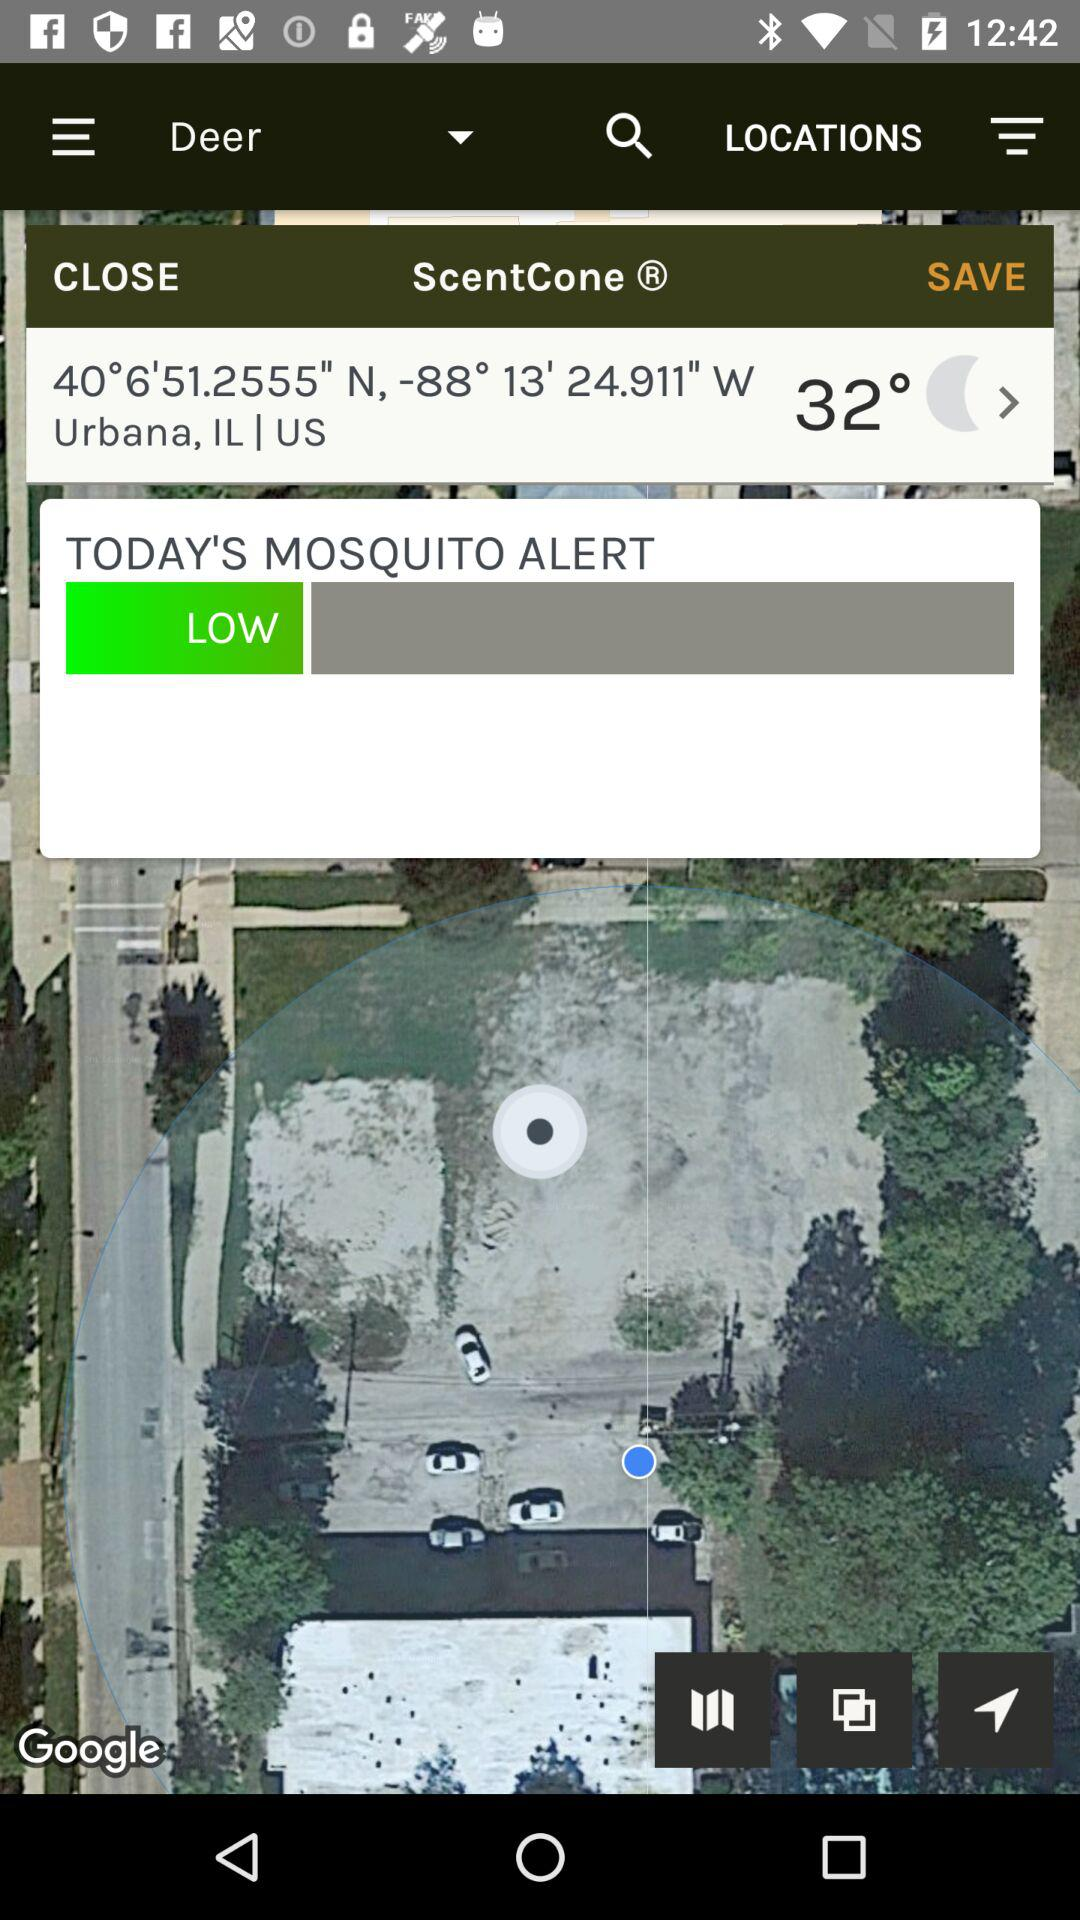What is today's mosquito alert? Today's mosquito alert is "LOW". 